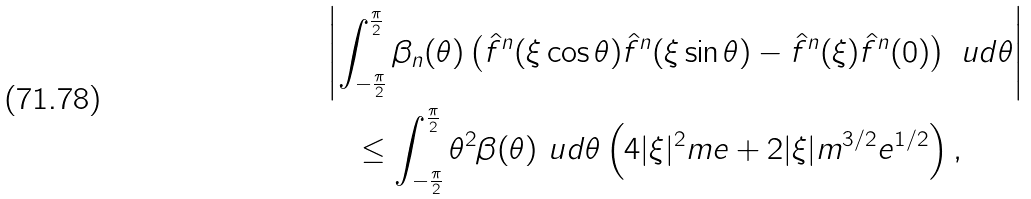Convert formula to latex. <formula><loc_0><loc_0><loc_500><loc_500>& \left | \int _ { - \frac { \pi } { 2 } } ^ { \frac { \pi } { 2 } } \beta _ { n } ( \theta ) \left ( \hat { f } ^ { n } ( \xi \cos \theta ) \hat { f } ^ { n } ( \xi \sin \theta ) - \hat { f } ^ { n } ( \xi ) \hat { f } ^ { n } ( 0 ) \right ) \ u d \theta \right | \\ & \quad \leq \int _ { - \frac { \pi } { 2 } } ^ { \frac { \pi } { 2 } } \theta ^ { 2 } \beta ( \theta ) \ u d \theta \left ( 4 | \xi | ^ { 2 } m e + 2 | \xi | m ^ { 3 / 2 } e ^ { 1 / 2 } \right ) ,</formula> 